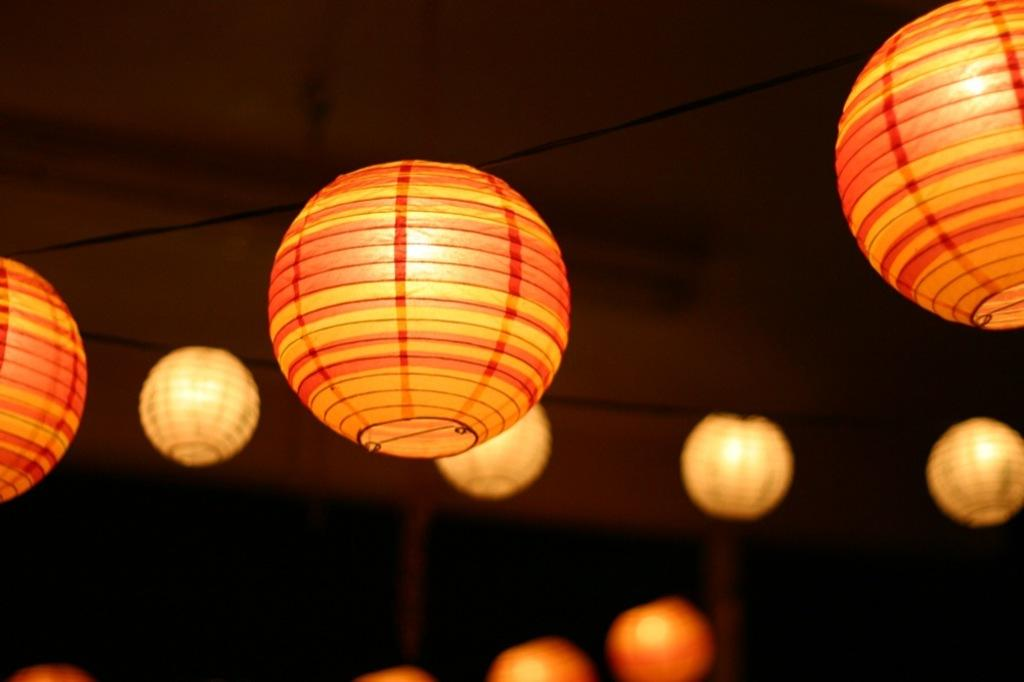What is hanging from the roof in the image? There are lights hanging from the roof in the image. How do the lights look like? The lights resemble balls. What is the general lighting condition in the room? The room appears to be dark. What part of the room is visible in the image? The roof is visible in the image. What type of butter is being used to record the sounds in the image? There is no butter or recording equipment present in the image. Can you see any dinosaurs in the image? There are no dinosaurs present in the image. 